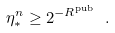<formula> <loc_0><loc_0><loc_500><loc_500>\eta _ { * } ^ { n } \geq 2 ^ { - R ^ { \text {pub} } } \ .</formula> 